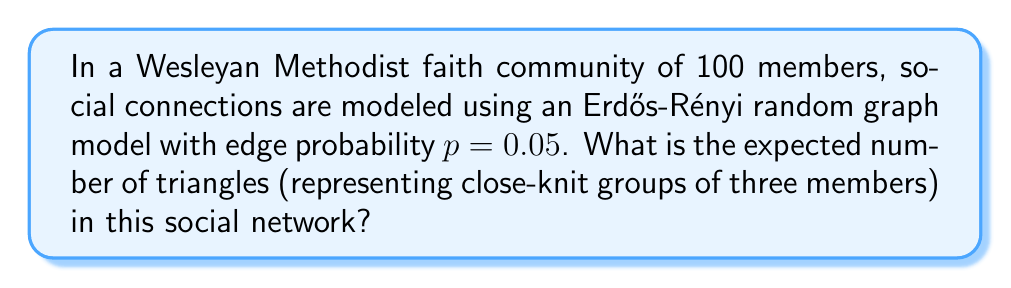What is the answer to this math problem? To solve this problem, we'll follow these steps:

1) In an Erdős-Rényi random graph model, each edge exists independently with probability $p$.

2) A triangle in the graph represents three members who are all connected to each other.

3) The number of possible triangles in a graph with $n$ vertices is $\binom{n}{3}$.

4) For a triangle to exist, all three edges that form it must be present. The probability of this happening is $p^3$.

5) The expected number of triangles is the product of the number of possible triangles and the probability of each triangle existing.

6) Let's calculate:
   
   $n = 100$ (number of members)
   $p = 0.05$ (edge probability)

   Number of possible triangles: $\binom{100}{3} = \frac{100!}{3!(100-3)!} = 161700$

   Probability of each triangle existing: $p^3 = 0.05^3 = 0.000125$

   Expected number of triangles: $161700 * 0.000125 = 20.2125$

Therefore, the expected number of triangles in this social network is approximately 20.2125.
Answer: 20.2125 